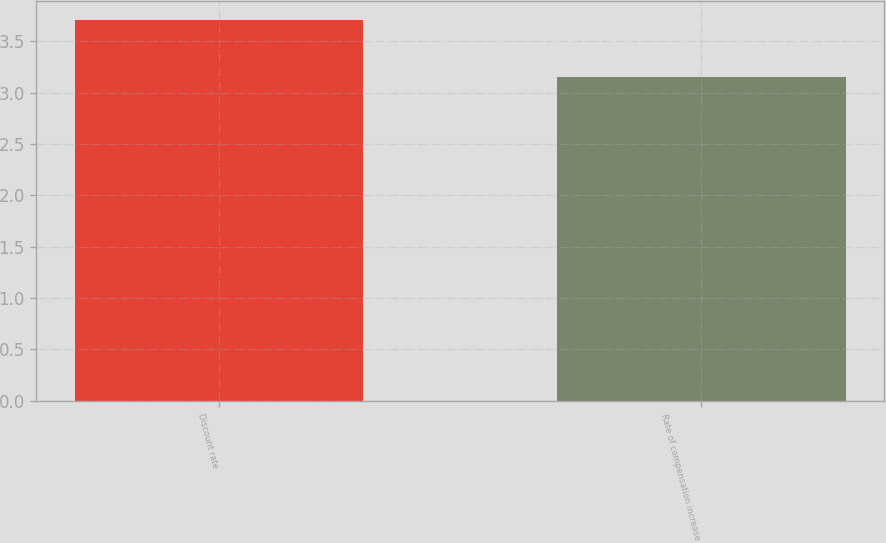Convert chart. <chart><loc_0><loc_0><loc_500><loc_500><bar_chart><fcel>Discount rate<fcel>Rate of compensation increase<nl><fcel>3.71<fcel>3.15<nl></chart> 